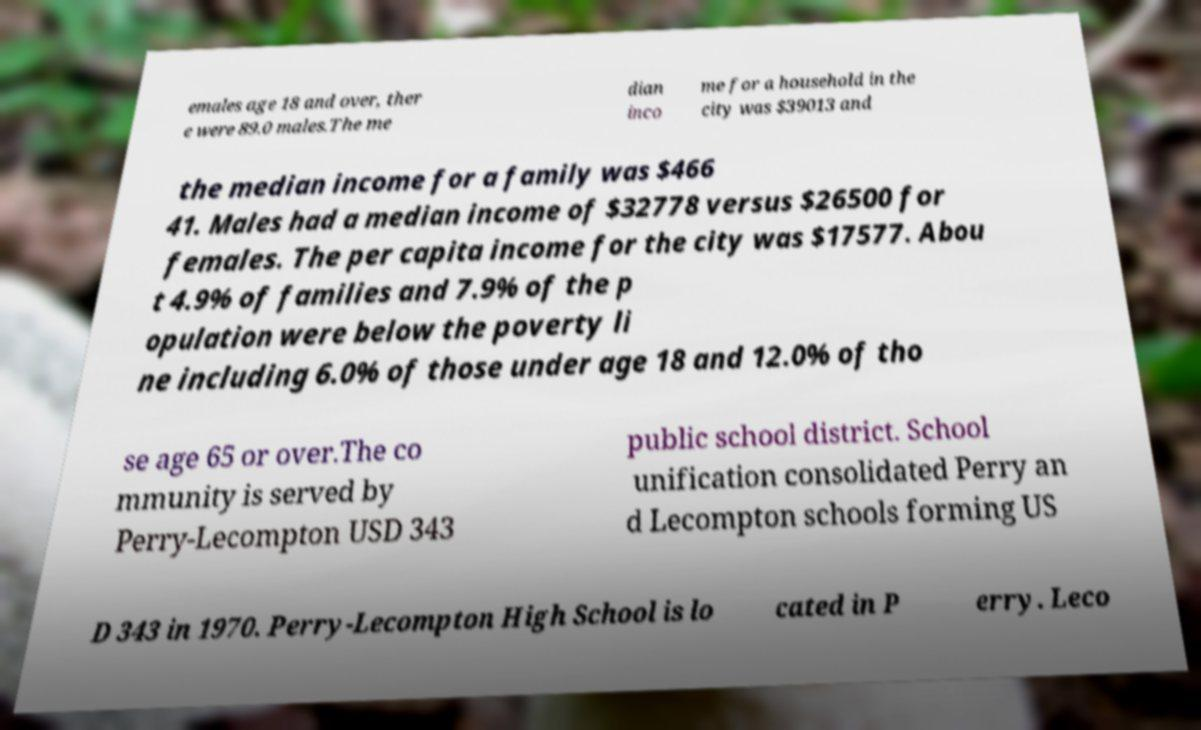Can you accurately transcribe the text from the provided image for me? emales age 18 and over, ther e were 89.0 males.The me dian inco me for a household in the city was $39013 and the median income for a family was $466 41. Males had a median income of $32778 versus $26500 for females. The per capita income for the city was $17577. Abou t 4.9% of families and 7.9% of the p opulation were below the poverty li ne including 6.0% of those under age 18 and 12.0% of tho se age 65 or over.The co mmunity is served by Perry-Lecompton USD 343 public school district. School unification consolidated Perry an d Lecompton schools forming US D 343 in 1970. Perry-Lecompton High School is lo cated in P erry. Leco 